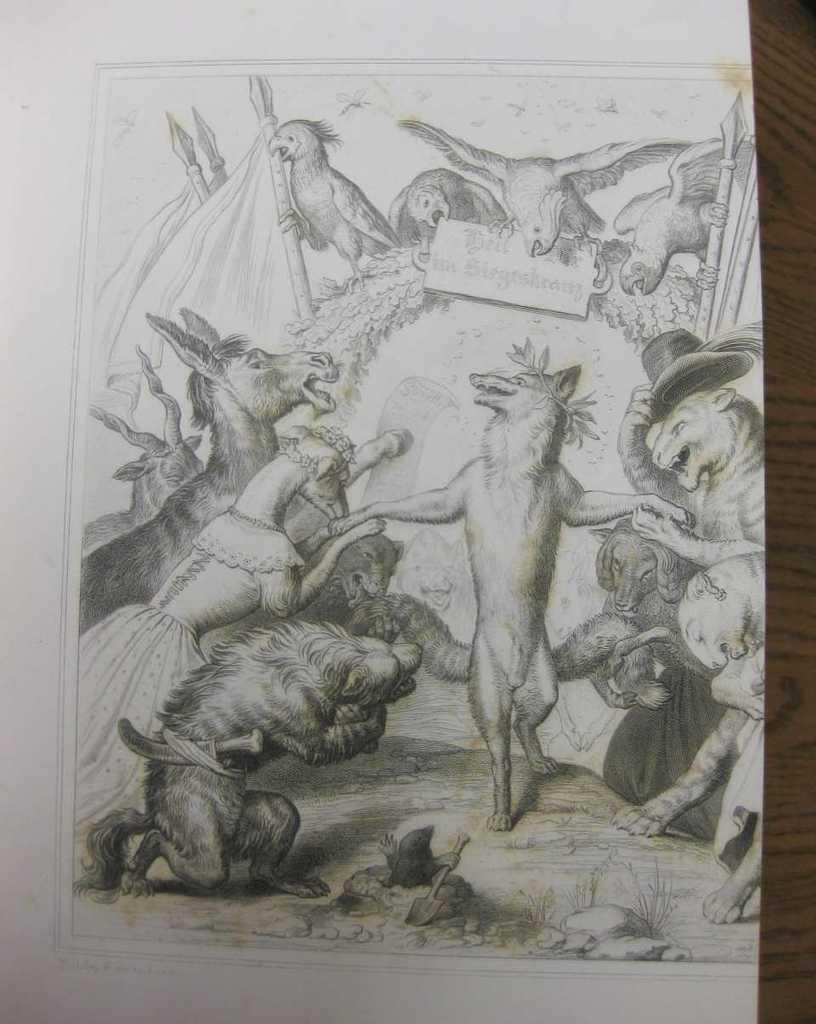What type of drawing technique is used in the image? The image is a pencil sketch. What is the main subject of the sketch? There are many animals in the sketch. What is the setting of the sketch? The animals are depicted in a jungle setting. What type of wax is used to create the texture of the animals' fur in the sketch? There is no wax used in the sketch; it is a pencil drawing. How does the artist convey a feeling of excitement in the sketch? The provided facts do not mention any specific emotions or feelings conveyed in the sketch. 